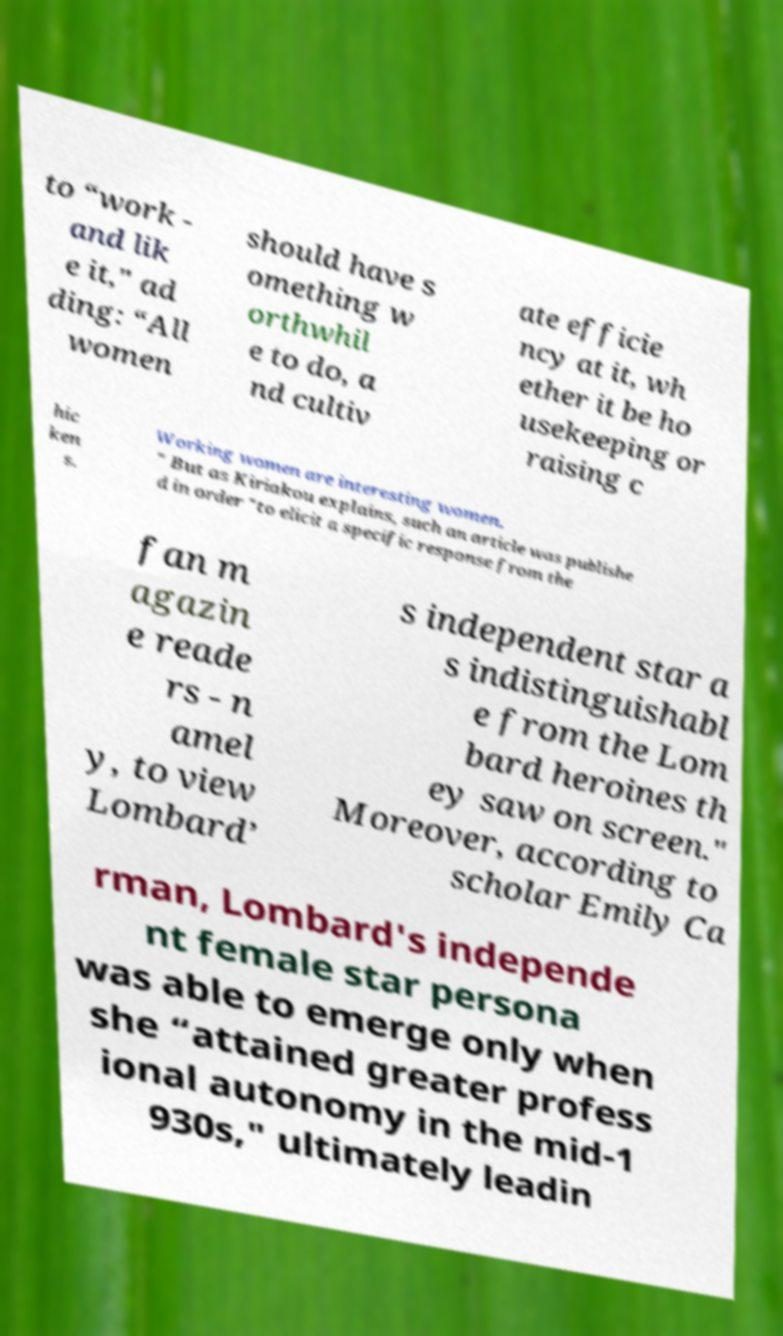Can you accurately transcribe the text from the provided image for me? to “work - and lik e it," ad ding: “All women should have s omething w orthwhil e to do, a nd cultiv ate efficie ncy at it, wh ether it be ho usekeeping or raising c hic ken s. Working women are interesting women. " But as Kiriakou explains, such an article was publishe d in order "to elicit a specific response from the fan m agazin e reade rs - n amel y, to view Lombard’ s independent star a s indistinguishabl e from the Lom bard heroines th ey saw on screen." Moreover, according to scholar Emily Ca rman, Lombard's independe nt female star persona was able to emerge only when she “attained greater profess ional autonomy in the mid-1 930s," ultimately leadin 